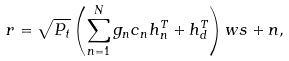<formula> <loc_0><loc_0><loc_500><loc_500>r = \sqrt { P _ { t } } \left ( \sum _ { n = 1 } ^ { N } g _ { n } c _ { n } h _ { n } ^ { T } + h _ { d } ^ { T } \right ) w s + n ,</formula> 